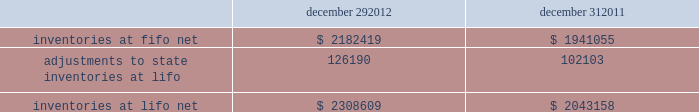In june 2011 , the fasb issued asu no .
2011-05 201ccomprehensive income 2013 presentation of comprehensive income . 201d asu 2011-05 requires comprehensive income , the components of net income , and the components of other comprehensive income either in a single continuous statement of comprehensive income or in two separate but consecutive statements .
In both choices , an entity is required to present each component of net income along with total net income , each component of other comprehensive income along with a total for other comprehensive income , and a total amount for comprehensive income .
This update eliminates the option to present the components of other comprehensive income as part of the statement of changes in stockholders' equity .
The amendments in this update do not change the items that must be reported in other comprehensive income or when an item of other comprehensive income must be reclassified to net income .
The amendments in this update should be applied retrospectively and is effective for interim and annual reporting periods beginning after december 15 , 2011 .
The company adopted this guidance in the first quarter of 2012 .
The adoption of asu 2011-05 is for presentation purposes only and had no material impact on the company 2019s consolidated financial statements .
Inventories , net : merchandise inventory the company used the lifo method of accounting for approximately 95% ( 95 % ) of inventories at both december 29 , 2012 and december 31 , 2011 .
Under lifo , the company 2019s cost of sales reflects the costs of the most recently purchased inventories , while the inventory carrying balance represents the costs for inventories purchased in fiscal 2012 and prior years .
The company recorded a reduction to cost of sales of $ 24087 and $ 29554 in fiscal 2012 and fiscal 2010 , respectively .
As a result of utilizing lifo , the company recorded an increase to cost of sales of $ 24708 for fiscal 2011 , due to an increase in supply chain costs and inflationary pressures affecting certain product categories .
The company 2019s overall costs to acquire inventory for the same or similar products have generally decreased historically as the company has been able to leverage its continued growth , execution of merchandise strategies and realization of supply chain efficiencies .
Product cores the remaining inventories are comprised of product cores , the non-consumable portion of certain parts and batteries , which are valued under the first-in , first-out ( "fifo" ) method .
Product cores are included as part of the company's merchandise costs and are either passed on to the customer or returned to the vendor .
Because product cores are not subject to frequent cost changes like the company's other merchandise inventory , there is no material difference when applying either the lifo or fifo valuation method .
Inventory overhead costs purchasing and warehousing costs included in inventory at december 29 , 2012 and december 31 , 2011 , were $ 134258 and $ 126840 , respectively .
Inventory balance and inventory reserves inventory balances at the end of fiscal 2012 and 2011 were as follows : december 29 , december 31 .
Inventory quantities are tracked through a perpetual inventory system .
The company completes physical inventories and other targeted inventory counts in its store locations to ensure the accuracy of the perpetual inventory quantities of both merchandise and core inventory in these locations .
In its distribution centers and pdq aes , the company uses a cycle counting program to ensure the accuracy of the perpetual inventory quantities of both merchandise and product core inventory .
Reserves advance auto parts , inc .
And subsidiaries notes to the consolidated financial statements december 29 , 2012 , december 31 , 2011 and january 1 , 2011 ( in thousands , except per share data ) .
How much did the cost of sales change over from 2010 to 2012? 
Rationale: to find the answer one must added the two years the cost of sales decreased then take the year that the cost of sales increased and subtract that by the previous answer .
Computations: (24708 - (24087 + 29554))
Answer: -28933.0. 